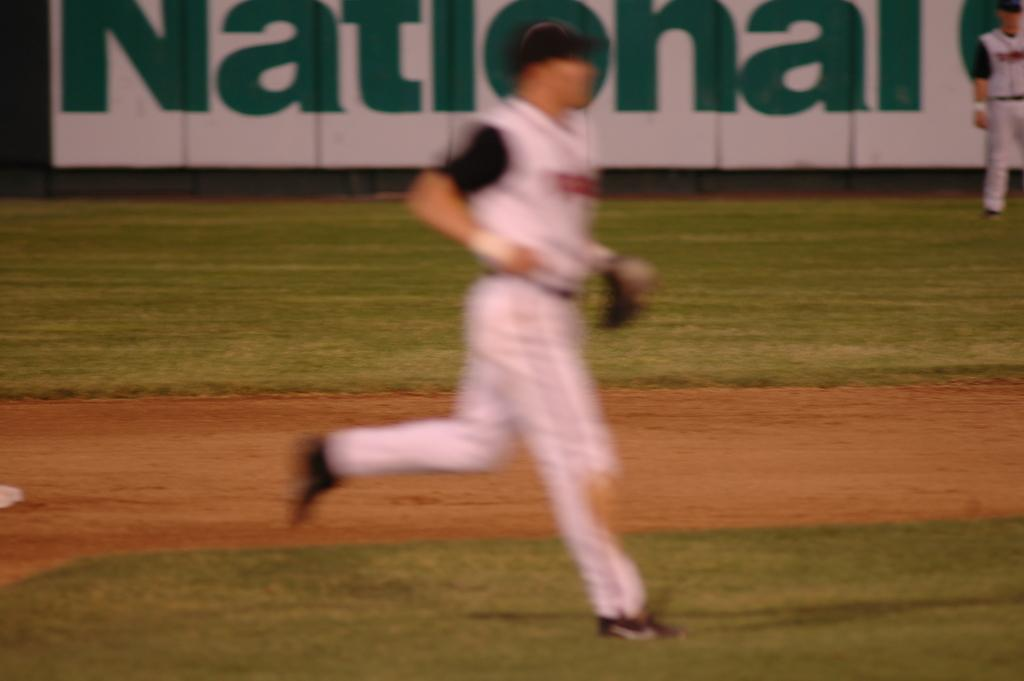<image>
Provide a brief description of the given image. A baseball player running on the field with National advertising behind him. 